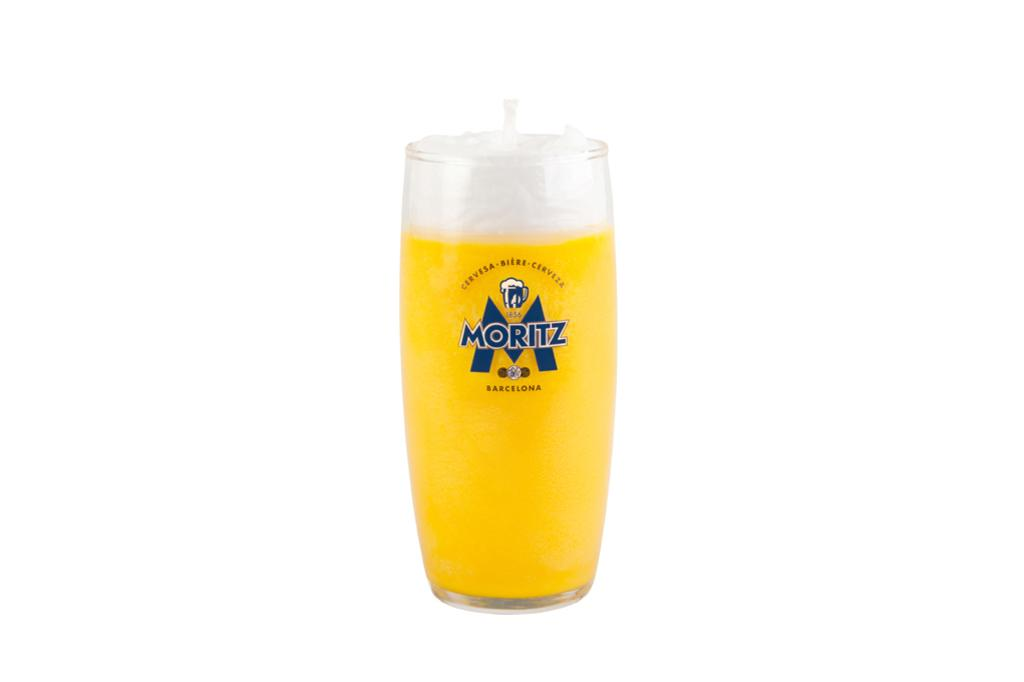<image>
Render a clear and concise summary of the photo. a glass of moritz beer set against a white background 